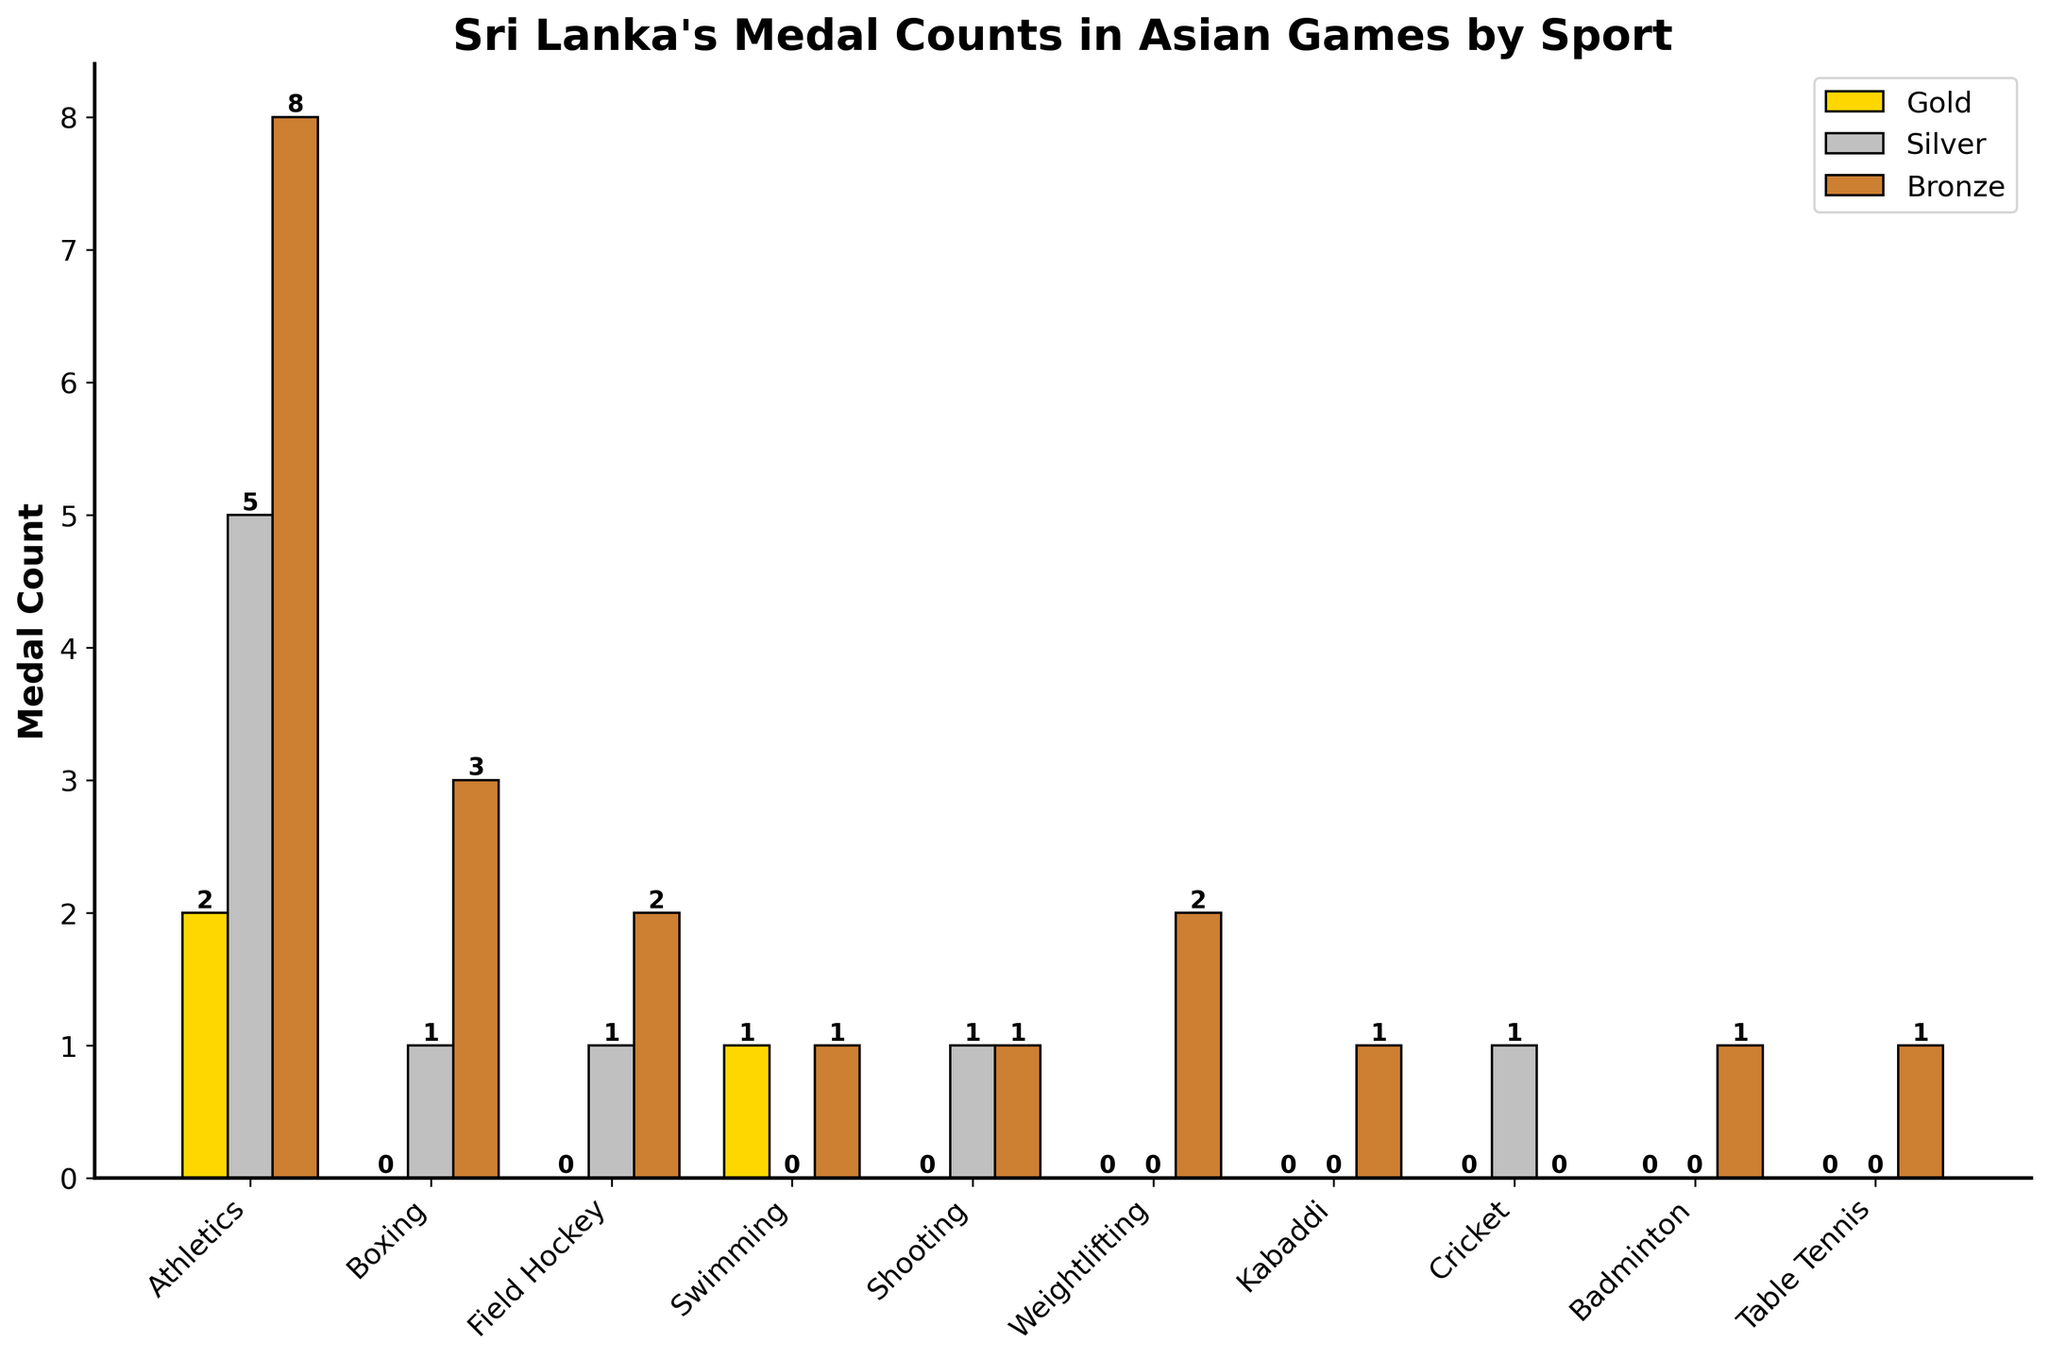What's the total number of silver medals won by Sri Lanka across all sports? Sum the values of the silver medals from each sport: 5 (Athletics) + 1 (Boxing) + 1 (Field Hockey) + 0 (Swimming) + 1 (Shooting) + 0 (Weightlifting) + 0 (Kabaddi) + 1 (Cricket) + 0 (Badminton) + 0 (Table Tennis) = 9
Answer: 9 Which sport has the highest number of gold medals? Check the gold medal counts for each sport and identify the maximum: Athletics has 2, Boxing has 0, Field Hockey has 0, Swimming has 1, Shooting has 0, Weightlifting has 0, Kabaddi has 0, Cricket has 0, Badminton has 0, Table Tennis has 0. Therefore, Athletics has the highest number of gold medals.
Answer: Athletics How many more bronze medals has Sri Lanka won in Field Hockey compared to Boxing? Subtract the number of bronze medals in Boxing from those in Field Hockey: 2 (Field Hockey) - 3 (Boxing) = -1, so Sri Lanka has won 1 fewer bronze medal in Field Hockey than in Boxing.
Answer: -1 What's the total medal count (gold, silver, bronze) for Swimming? Add the gold, silver, and bronze medals for Swimming: 1 (gold) + 0 (silver) + 1 (bronze) = 2
Answer: 2 Which sport has an equal number of silver and bronze medals? Check if any sport has the same count for silver and bronze medals: Shooting has 1 (silver) and 1 (bronze).
Answer: Shooting What's the difference between the total number of gold and bronze medals in Athletics? Athletics has 2 gold medals and 8 bronze medals. The difference is 8 - 2 = 6
Answer: 6 How many sports have won at least one gold medal for Sri Lanka? Count the sports with at least one gold medal: Athletics (2) and Swimming (1). Thus, 2 sports.
Answer: 2 In which sport does the height of the silver medal bar exceed that of both the gold and bronze medal bars? By visually inspecting the bars, Field Hockey has a taller silver medal bar (1) than both its gold (0) and bronze (2) bars.
Answer: Field Hockey Which sport has the lowest total number of medals? Sum the total medals for each sport and identify the minimum: Kabaddi and Badminton each have 1 bronze medal, which is the smallest total.
Answer: Kabaddi and Badminton 